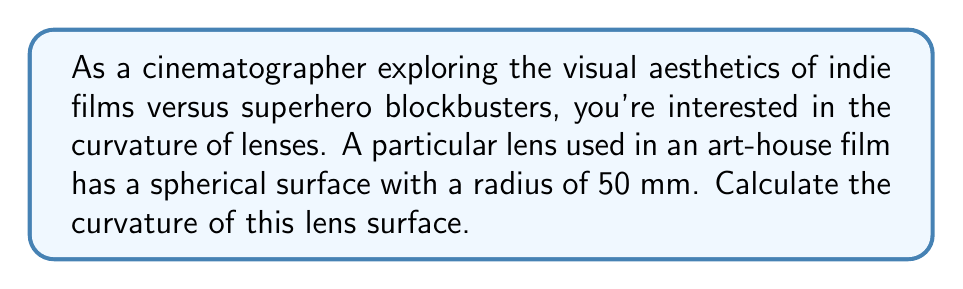Give your solution to this math problem. To solve this problem, we need to understand the relationship between curvature and radius:

1) The curvature (κ) of a spherical surface is defined as the reciprocal of its radius (r):

   $$ κ = \frac{1}{r} $$

2) We are given that the radius of the lens surface is 50 mm.

3) Substituting this value into our equation:

   $$ κ = \frac{1}{50 \text{ mm}} $$

4) Simplifying:

   $$ κ = 0.02 \text{ mm}^{-1} $$

5) Note that the units of curvature are the reciprocal of the units of radius. In this case, it's mm^-1.

This curvature value indicates how sharply the lens surface bends. A higher value would indicate a more pronounced curve, which could potentially create more dramatic visual effects - something to consider when comparing the cinematography of indie films to superhero blockbusters.
Answer: $0.02 \text{ mm}^{-1}$ 